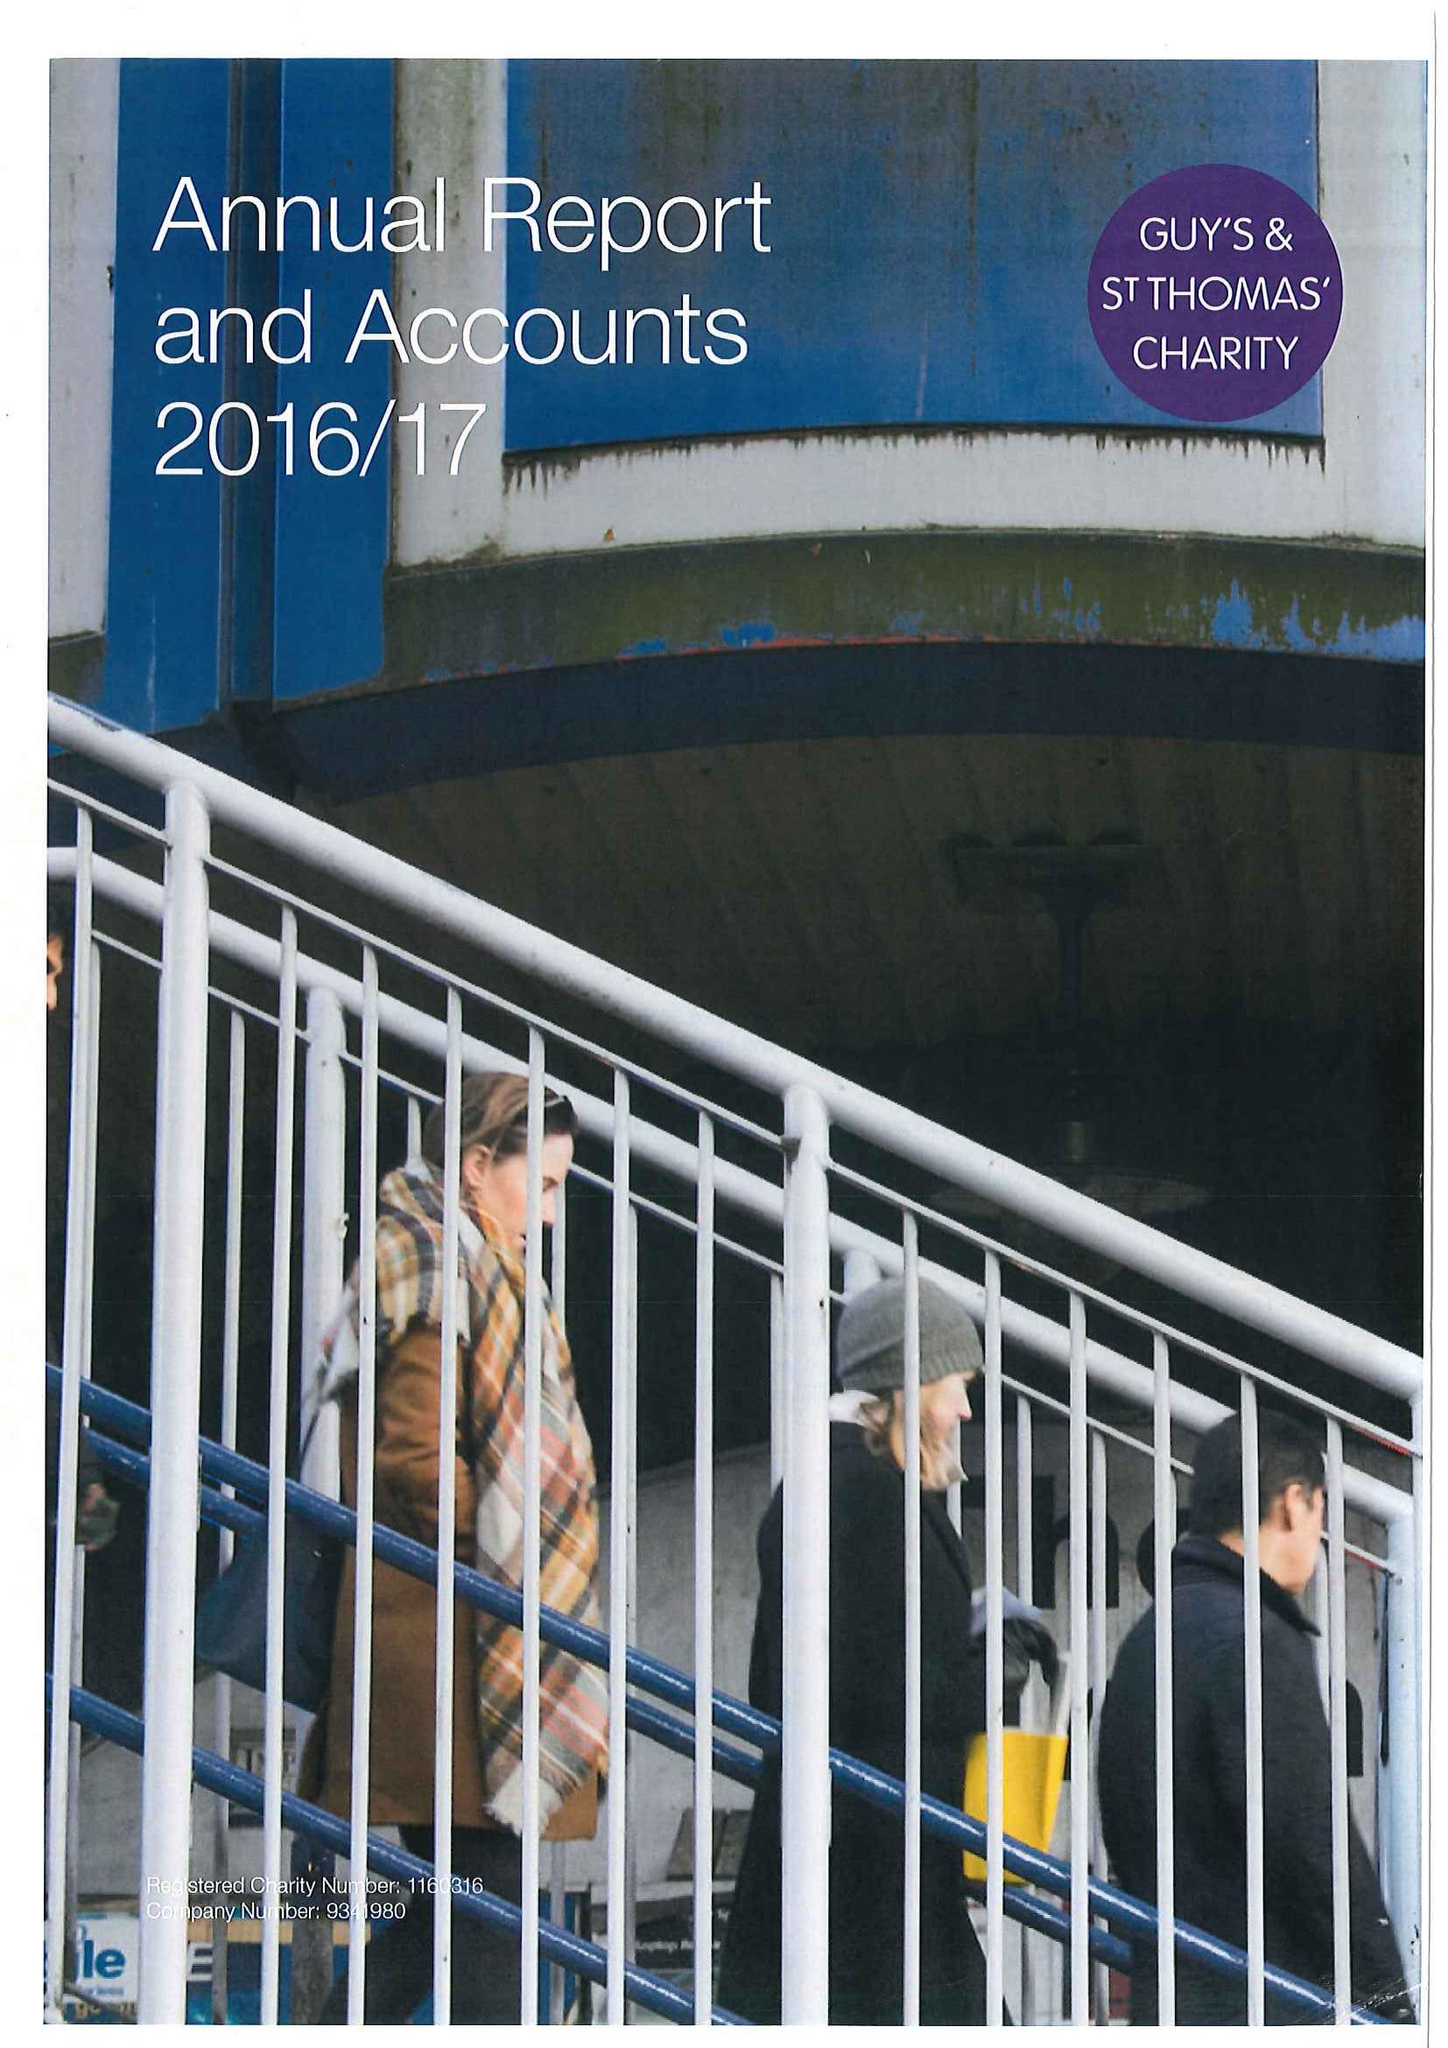What is the value for the address__postcode?
Answer the question using a single word or phrase. SE1 1NA 